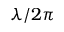Convert formula to latex. <formula><loc_0><loc_0><loc_500><loc_500>\lambda / 2 \pi</formula> 